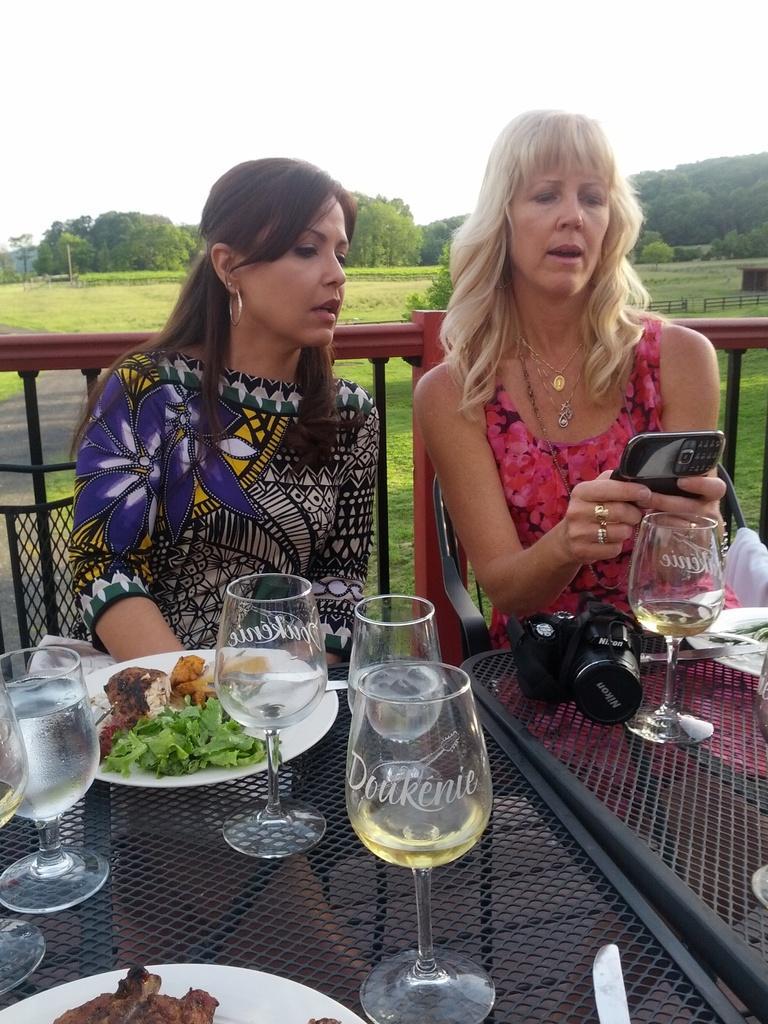Could you give a brief overview of what you see in this image? On the right there is a woman she wear pink dress her hair is short she is sitting on the chair she is holding mobile phone. On the left there is a woman her hair is short. In the middle there is a table on the table there is glass,plate ,camera some other items. In the background there are trees ,hill,sky ,plant and grass. 